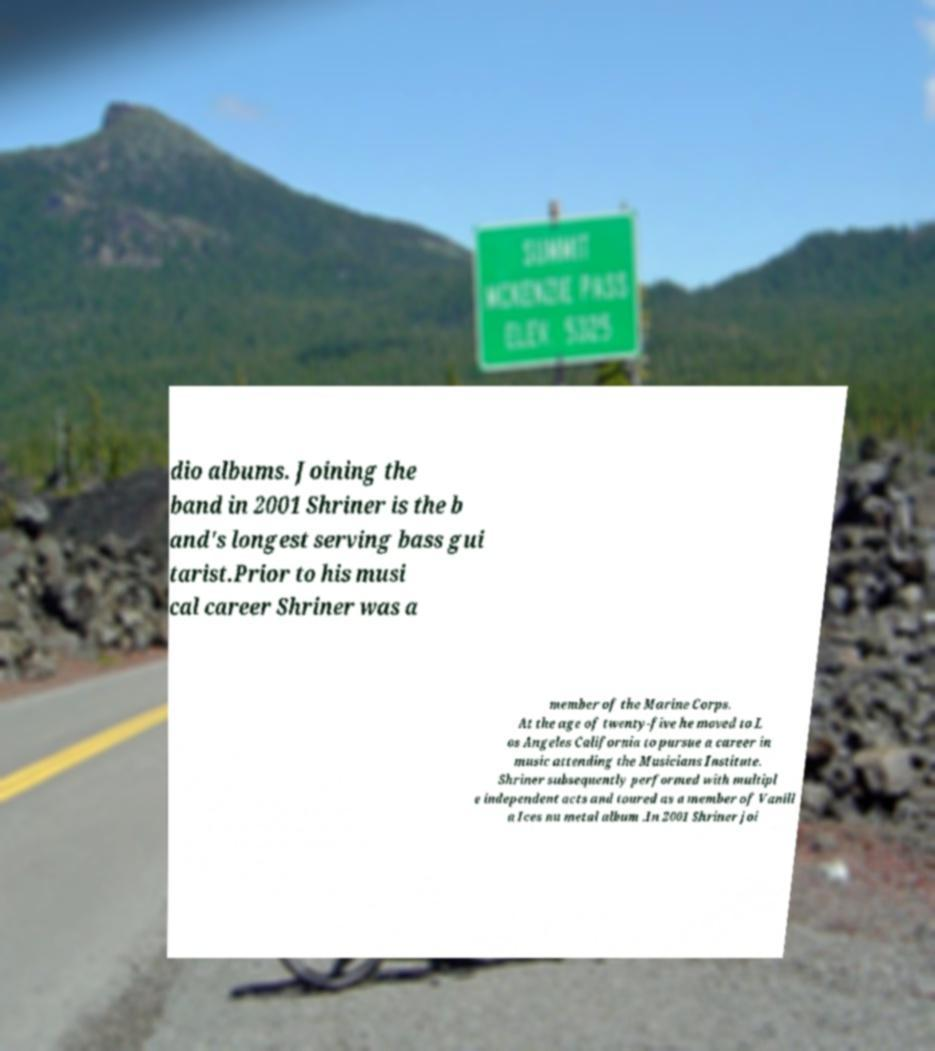For documentation purposes, I need the text within this image transcribed. Could you provide that? dio albums. Joining the band in 2001 Shriner is the b and's longest serving bass gui tarist.Prior to his musi cal career Shriner was a member of the Marine Corps. At the age of twenty-five he moved to L os Angeles California to pursue a career in music attending the Musicians Institute. Shriner subsequently performed with multipl e independent acts and toured as a member of Vanill a Ices nu metal album .In 2001 Shriner joi 